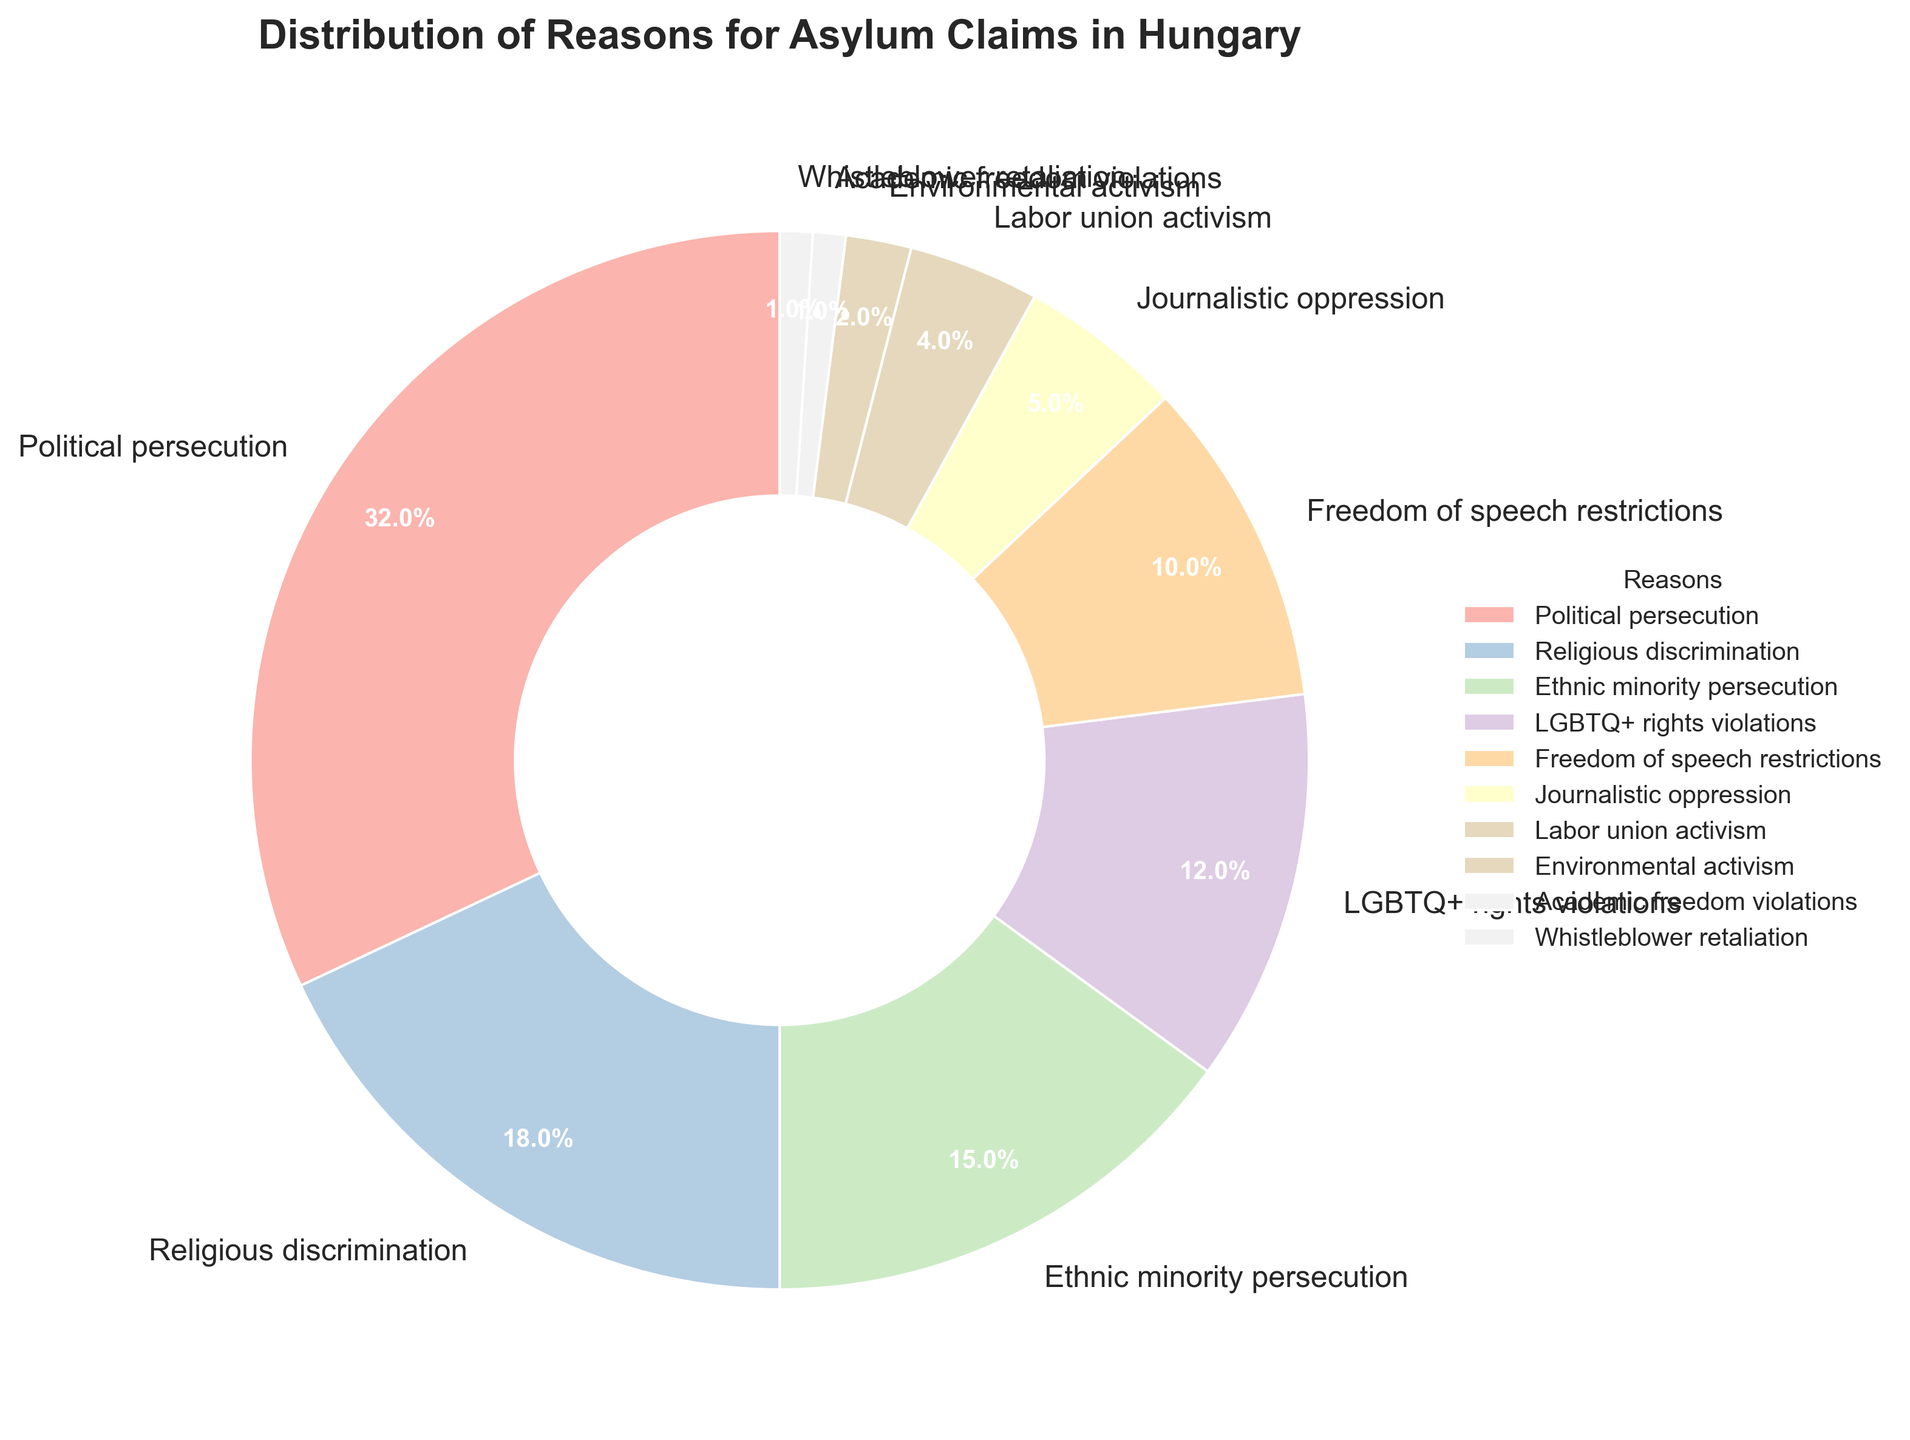What is the most common reason for asylum claims in Hungary? The figure shows that "Political persecution" has the largest section with 32%, making it the most common reason for asylum claims in Hungary.
Answer: Political persecution What are the combined percentages for "Political persecution" and "Religious discrimination"? Adding the percentages for "Political persecution" (32%) and "Religious discrimination" (18%) gives a total of 50%.
Answer: 50% Which is higher, the percentage for "Ethnic minority persecution" or "LGBTQ+ rights violations"? Reviewing the pie chart, "Ethnic minority persecution" accounts for 15%, whereas "LGBTQ+ rights violations" make up 12%. Therefore, "Ethnic minority persecution" is higher.
Answer: Ethnic minority persecution How much larger is the percentage for "Political persecution" compared to "Journalistic oppression"? "Political persecution" is at 32%, and "Journalistic oppression" is at 5%. Therefore, the difference is 32% - 5% = 27%.
Answer: 27% How many reasons have a percentage less than 5%? By looking at the pie chart, the reasons with percentages less than 5% are "Labor union activism" (4%), "Environmental activism" (2%), "Academic freedom violations" (1%), and "Whistleblower retaliation" (1%). There are four such reasons.
Answer: 4 Which color represents "Religious discrimination"? The pie chart uses different shades from the Pastel1 color palette. "Religious discrimination" is the second segment, which is usually a distinct pastel color, such as light pink or a similar hue.
Answer: Light pink (or equivalent pastel shade) What is the total percentage of all reasons related to activism? "Labor union activism" is 4%, and "Environmental activism" is 2%. Adding these together, 4% + 2% = 6%.
Answer: 6% Rank the reasons from highest to lowest percentage. The percentages from the pie chart are: Political persecution (32%), Religious discrimination (18%), Ethnic minority persecution (15%), LGBTQ+ rights violations (12%), Freedom of speech restrictions (10%), Journalistic oppression (5%), Labor union activism (4%), Environmental activism (2%), Academic freedom violations (1%), Whistleblower retaliation (1%).
Answer: Political persecution > Religious discrimination > Ethnic minority persecution > LGBTQ+ rights violations > Freedom of speech restrictions > Journalistic oppression > Labor union activism > Environmental activism > Academic freedom violations = Whistleblower retaliation How does the percentage of "Freedom of speech restrictions" compare to that of "LGBTQ+ rights violations"? The pie chart shows that "Freedom of speech restrictions" is 10% and "LGBTQ+ rights violations" is 12%. Therefore, "LGBTQ+ rights violations" is higher.
Answer: LGBTQ+ rights violations 